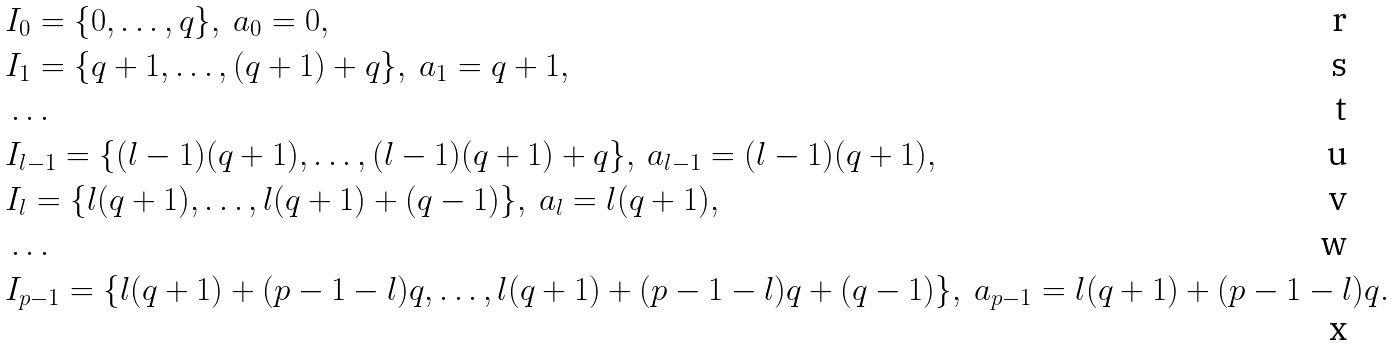Convert formula to latex. <formula><loc_0><loc_0><loc_500><loc_500>& I _ { 0 } = \{ 0 , \dots , q \} , \ a _ { 0 } = 0 , \\ & I _ { 1 } = \{ q + 1 , \dots , ( q + 1 ) + q \} , \ a _ { 1 } = q + 1 , \\ & \dots \\ & I _ { l - 1 } = \{ ( l - 1 ) ( q + 1 ) , \dots , ( l - 1 ) ( q + 1 ) + q \} , \ a _ { l - 1 } = ( l - 1 ) ( q + 1 ) , \\ & I _ { l } = \{ l ( q + 1 ) , \dots , l ( q + 1 ) + ( q - 1 ) \} , \ a _ { l } = l ( q + 1 ) , \\ & \dots \\ & I _ { p - 1 } = \{ l ( q + 1 ) + ( p - 1 - l ) q , \dots , l ( q + 1 ) + ( p - 1 - l ) q + ( q - 1 ) \} , \ a _ { p - 1 } = l ( q + 1 ) + ( p - 1 - l ) q .</formula> 